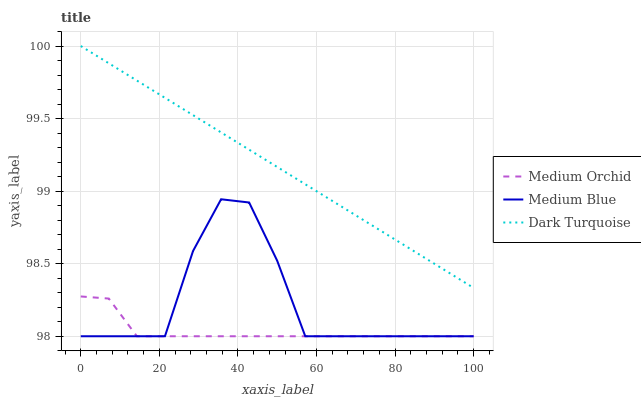Does Medium Orchid have the minimum area under the curve?
Answer yes or no. Yes. Does Dark Turquoise have the maximum area under the curve?
Answer yes or no. Yes. Does Medium Blue have the minimum area under the curve?
Answer yes or no. No. Does Medium Blue have the maximum area under the curve?
Answer yes or no. No. Is Dark Turquoise the smoothest?
Answer yes or no. Yes. Is Medium Blue the roughest?
Answer yes or no. Yes. Is Medium Orchid the smoothest?
Answer yes or no. No. Is Medium Orchid the roughest?
Answer yes or no. No. Does Dark Turquoise have the highest value?
Answer yes or no. Yes. Does Medium Blue have the highest value?
Answer yes or no. No. Is Medium Orchid less than Dark Turquoise?
Answer yes or no. Yes. Is Dark Turquoise greater than Medium Orchid?
Answer yes or no. Yes. Does Medium Orchid intersect Medium Blue?
Answer yes or no. Yes. Is Medium Orchid less than Medium Blue?
Answer yes or no. No. Is Medium Orchid greater than Medium Blue?
Answer yes or no. No. Does Medium Orchid intersect Dark Turquoise?
Answer yes or no. No. 